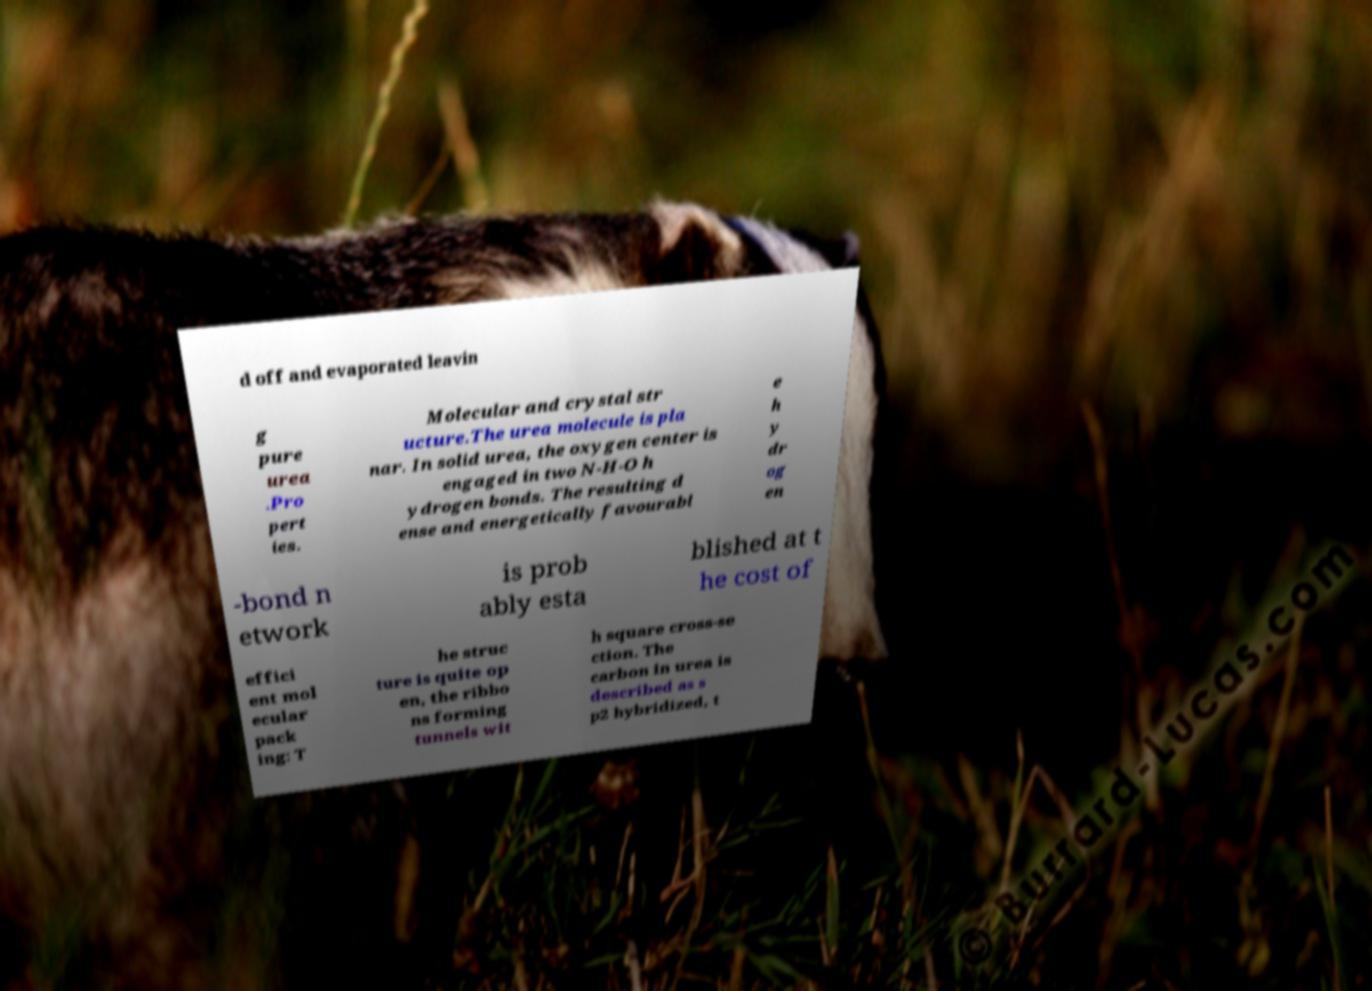Can you read and provide the text displayed in the image?This photo seems to have some interesting text. Can you extract and type it out for me? d off and evaporated leavin g pure urea .Pro pert ies. Molecular and crystal str ucture.The urea molecule is pla nar. In solid urea, the oxygen center is engaged in two N-H-O h ydrogen bonds. The resulting d ense and energetically favourabl e h y dr og en -bond n etwork is prob ably esta blished at t he cost of effici ent mol ecular pack ing: T he struc ture is quite op en, the ribbo ns forming tunnels wit h square cross-se ction. The carbon in urea is described as s p2 hybridized, t 